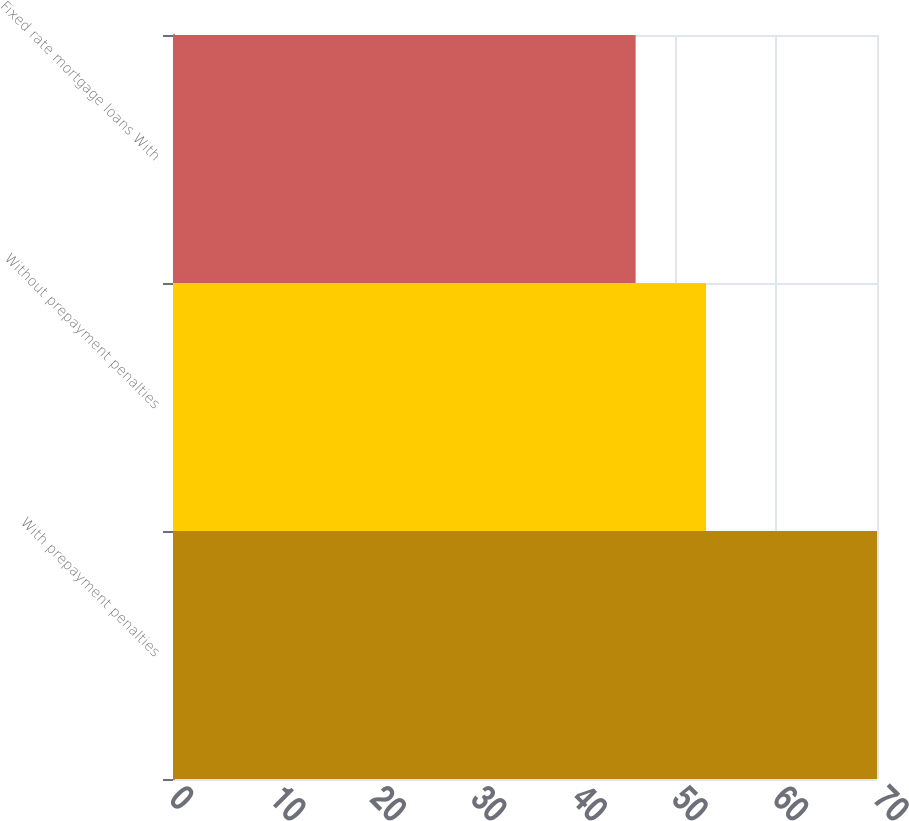Convert chart. <chart><loc_0><loc_0><loc_500><loc_500><bar_chart><fcel>With prepayment penalties<fcel>Without prepayment penalties<fcel>Fixed rate mortgage loans With<nl><fcel>70<fcel>53<fcel>46<nl></chart> 